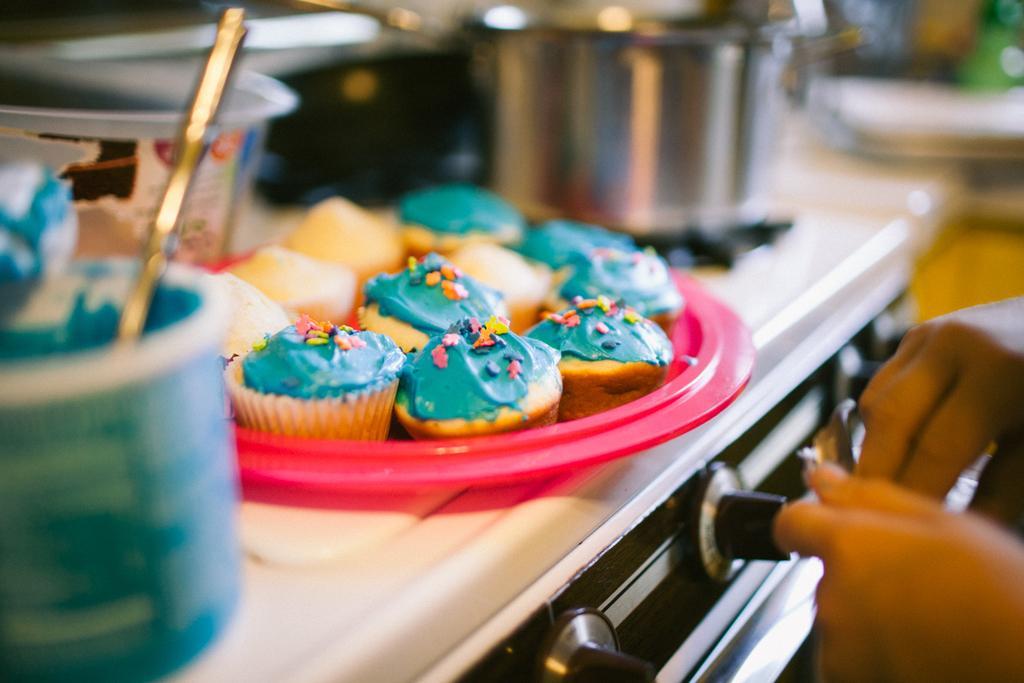Please provide a concise description of this image. In this picture we can see few cupcakes, bowls and other things on the stove, on the right hand side we can see human hands. 